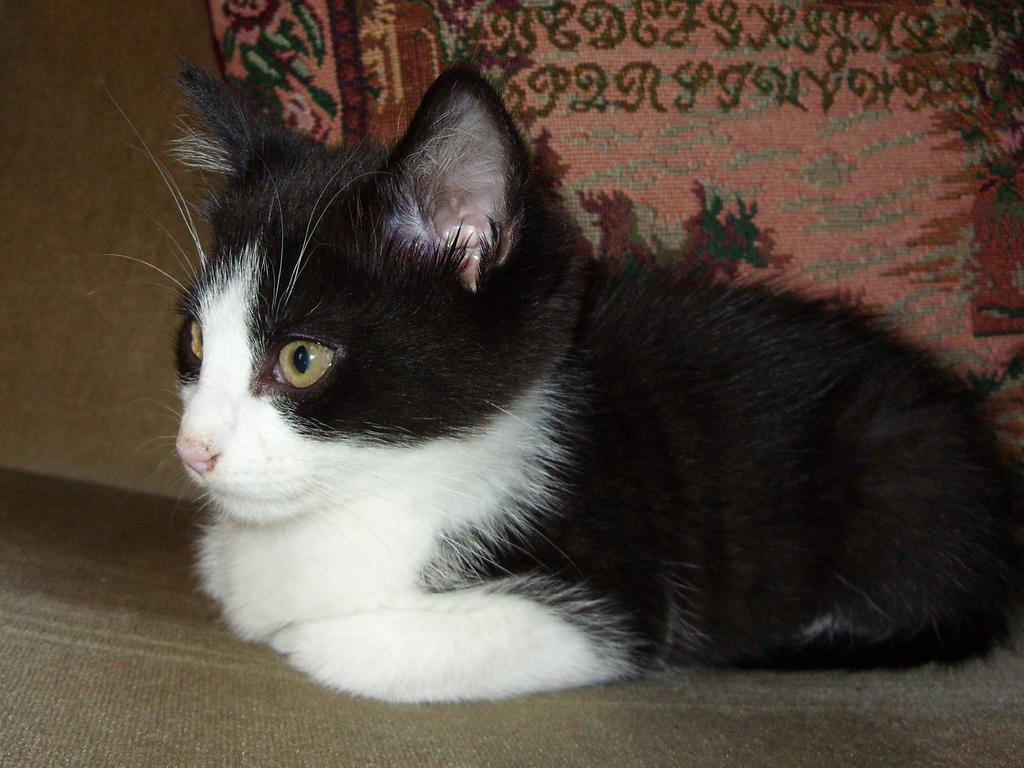What type of animal is in the image? There is a black and white cat in the image. Where is the cat located in the image? The cat is in the middle of the image. What other object can be seen in the image? There is a pillow in the image. Where is the pillow located in the image? The pillow is on the top of the image. What type of horn can be heard in the image? There is no horn present in the image, and therefore no sound can be heard. 